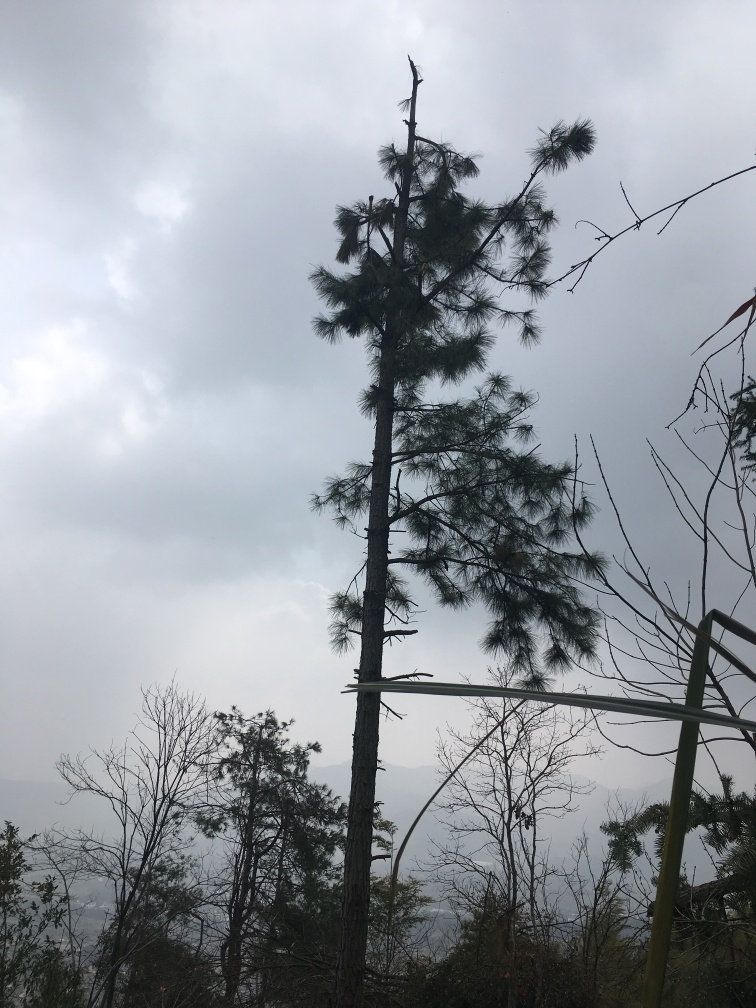Is there any sign of wildlife or human activity in the image? There are no clear indications of wildlife or human activities in the visible portion of the image. The natural setting seems undisturbed, without any animals or people, nor any visible man-made structures or paths. 